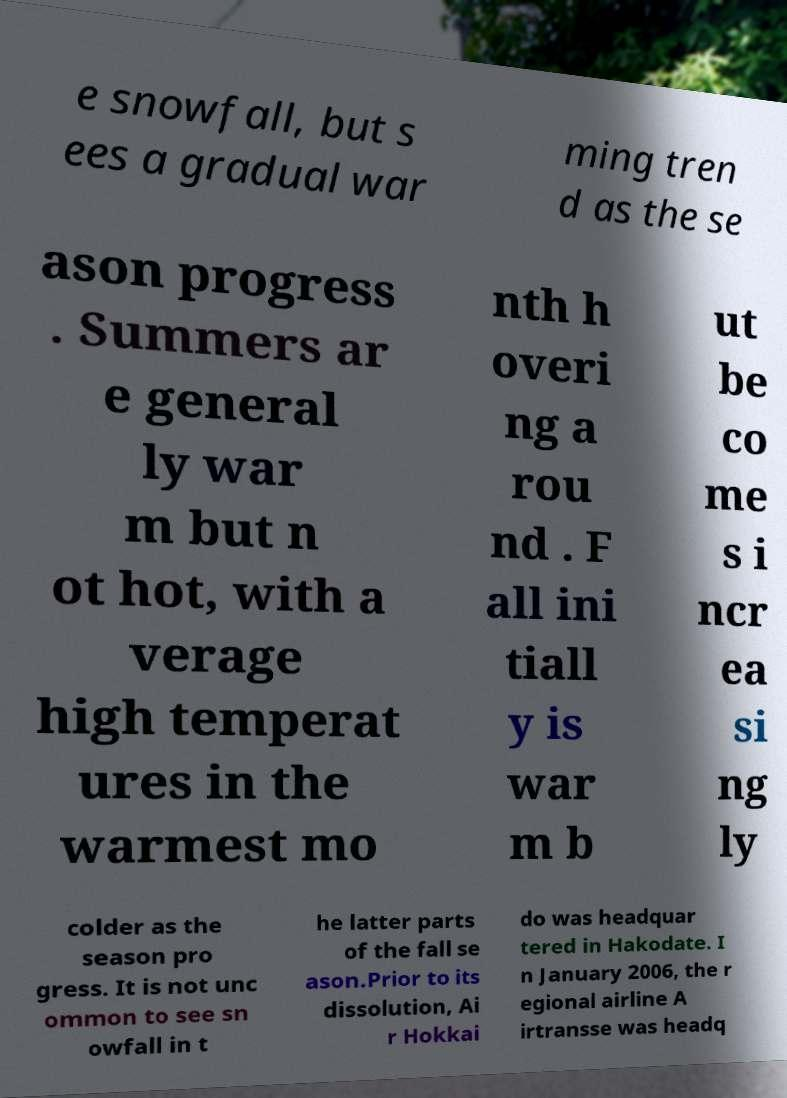I need the written content from this picture converted into text. Can you do that? e snowfall, but s ees a gradual war ming tren d as the se ason progress . Summers ar e general ly war m but n ot hot, with a verage high temperat ures in the warmest mo nth h overi ng a rou nd . F all ini tiall y is war m b ut be co me s i ncr ea si ng ly colder as the season pro gress. It is not unc ommon to see sn owfall in t he latter parts of the fall se ason.Prior to its dissolution, Ai r Hokkai do was headquar tered in Hakodate. I n January 2006, the r egional airline A irtransse was headq 